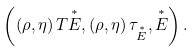<formula> <loc_0><loc_0><loc_500><loc_500>\left ( \left ( \rho , \eta \right ) T \overset { \ast } { E } , \left ( \rho , \eta \right ) \tau _ { \overset { \ast } { E } } , \overset { \ast } { E } \right ) .</formula> 